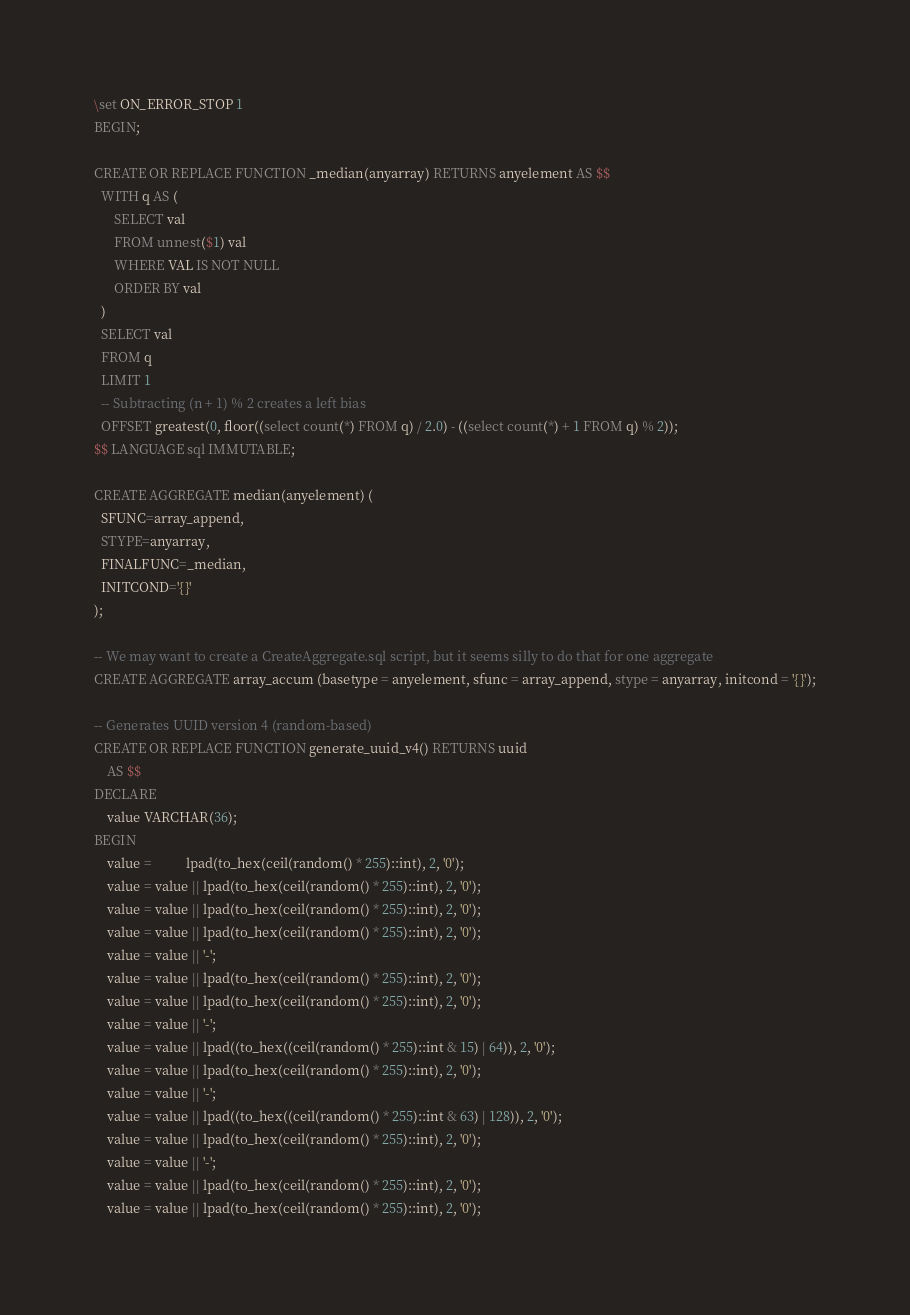Convert code to text. <code><loc_0><loc_0><loc_500><loc_500><_SQL_>\set ON_ERROR_STOP 1
BEGIN;

CREATE OR REPLACE FUNCTION _median(anyarray) RETURNS anyelement AS $$
  WITH q AS (
      SELECT val
      FROM unnest($1) val
      WHERE VAL IS NOT NULL
      ORDER BY val
  )
  SELECT val
  FROM q
  LIMIT 1
  -- Subtracting (n + 1) % 2 creates a left bias
  OFFSET greatest(0, floor((select count(*) FROM q) / 2.0) - ((select count(*) + 1 FROM q) % 2));
$$ LANGUAGE sql IMMUTABLE;

CREATE AGGREGATE median(anyelement) (
  SFUNC=array_append,
  STYPE=anyarray,
  FINALFUNC=_median,
  INITCOND='{}'
);

-- We may want to create a CreateAggregate.sql script, but it seems silly to do that for one aggregate
CREATE AGGREGATE array_accum (basetype = anyelement, sfunc = array_append, stype = anyarray, initcond = '{}');

-- Generates UUID version 4 (random-based)
CREATE OR REPLACE FUNCTION generate_uuid_v4() RETURNS uuid
    AS $$
DECLARE
    value VARCHAR(36);
BEGIN
    value =          lpad(to_hex(ceil(random() * 255)::int), 2, '0');
    value = value || lpad(to_hex(ceil(random() * 255)::int), 2, '0');
    value = value || lpad(to_hex(ceil(random() * 255)::int), 2, '0');
    value = value || lpad(to_hex(ceil(random() * 255)::int), 2, '0');
    value = value || '-';
    value = value || lpad(to_hex(ceil(random() * 255)::int), 2, '0');
    value = value || lpad(to_hex(ceil(random() * 255)::int), 2, '0');
    value = value || '-';
    value = value || lpad((to_hex((ceil(random() * 255)::int & 15) | 64)), 2, '0');
    value = value || lpad(to_hex(ceil(random() * 255)::int), 2, '0');
    value = value || '-';
    value = value || lpad((to_hex((ceil(random() * 255)::int & 63) | 128)), 2, '0');
    value = value || lpad(to_hex(ceil(random() * 255)::int), 2, '0');
    value = value || '-';
    value = value || lpad(to_hex(ceil(random() * 255)::int), 2, '0');
    value = value || lpad(to_hex(ceil(random() * 255)::int), 2, '0');</code> 